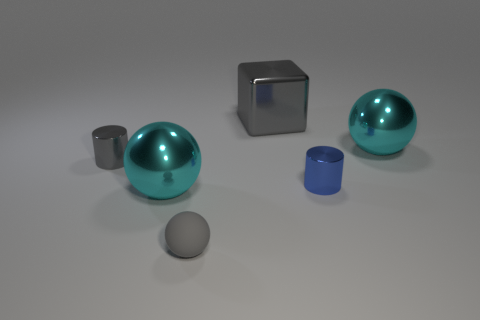What color is the other tiny cylinder that is the same material as the small gray cylinder?
Make the answer very short. Blue. Is the tiny cylinder that is in front of the tiny gray cylinder made of the same material as the cylinder on the left side of the large cube?
Make the answer very short. Yes. Is there another block of the same size as the gray metal block?
Provide a short and direct response. No. There is a metallic thing to the left of the metal sphere that is on the left side of the large gray metallic cube; what size is it?
Provide a short and direct response. Small. What number of big things are the same color as the rubber ball?
Keep it short and to the point. 1. The tiny metallic object that is right of the big gray metallic cube that is behind the gray cylinder is what shape?
Your response must be concise. Cylinder. What number of large cyan objects have the same material as the tiny blue cylinder?
Provide a succinct answer. 2. What material is the gray object that is behind the tiny gray metallic cylinder?
Keep it short and to the point. Metal. The tiny metal thing on the right side of the gray metallic thing that is behind the big cyan metallic sphere behind the small gray cylinder is what shape?
Offer a very short reply. Cylinder. There is a metallic sphere that is on the right side of the gray shiny cube; does it have the same color as the tiny cylinder that is to the right of the gray cube?
Your answer should be compact. No. 